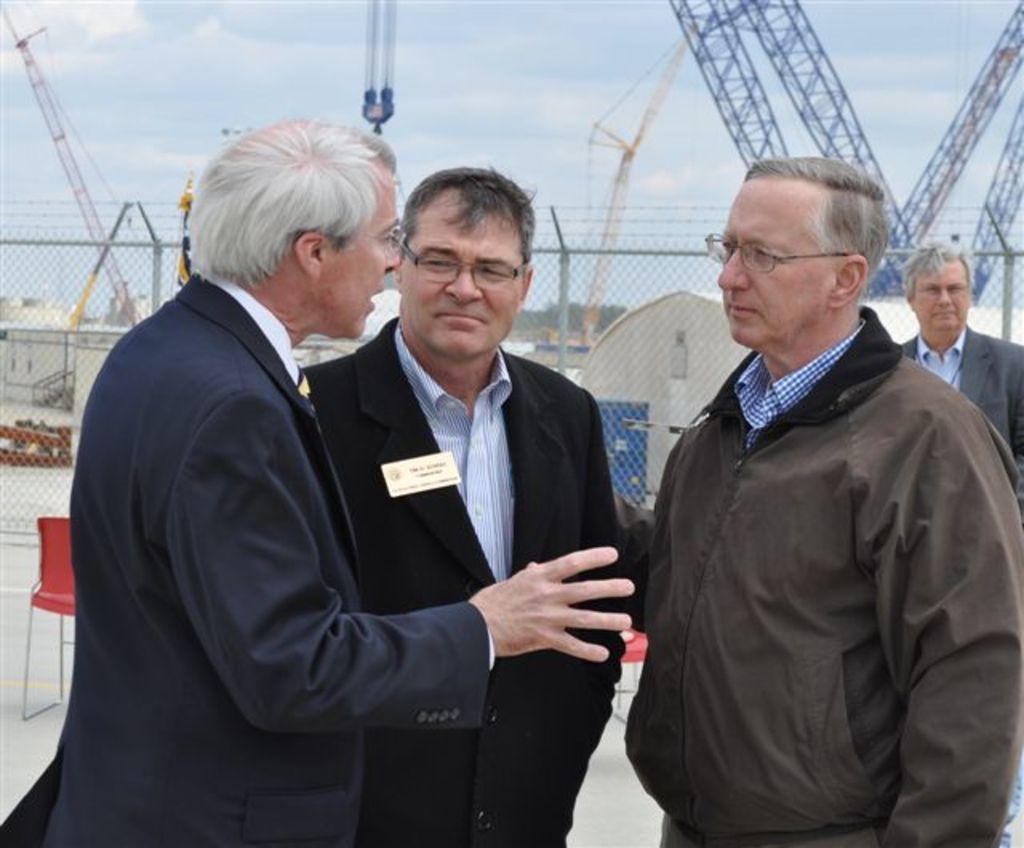Please provide a concise description of this image. There are four men in the image, three of them were standing in the front and one person is talking, behind the men there is a mesh and in the background there are some other machines. 